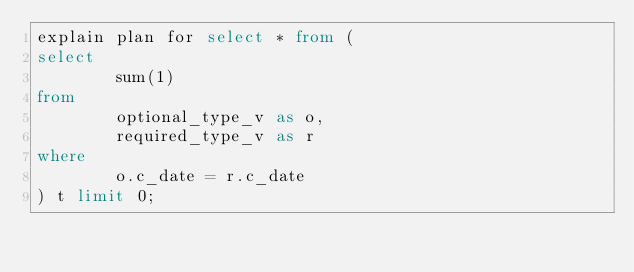Convert code to text. <code><loc_0><loc_0><loc_500><loc_500><_SQL_>explain plan for select * from (
select 
        sum(1)
from 
        optional_type_v as o,
        required_type_v as r
where
        o.c_date = r.c_date
) t limit 0;
</code> 